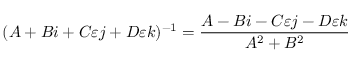Convert formula to latex. <formula><loc_0><loc_0><loc_500><loc_500>( A + B i + C \varepsilon j + D \varepsilon k ) ^ { - 1 } = { \frac { A - B i - C \varepsilon j - D \varepsilon k } { A ^ { 2 } + B ^ { 2 } } }</formula> 